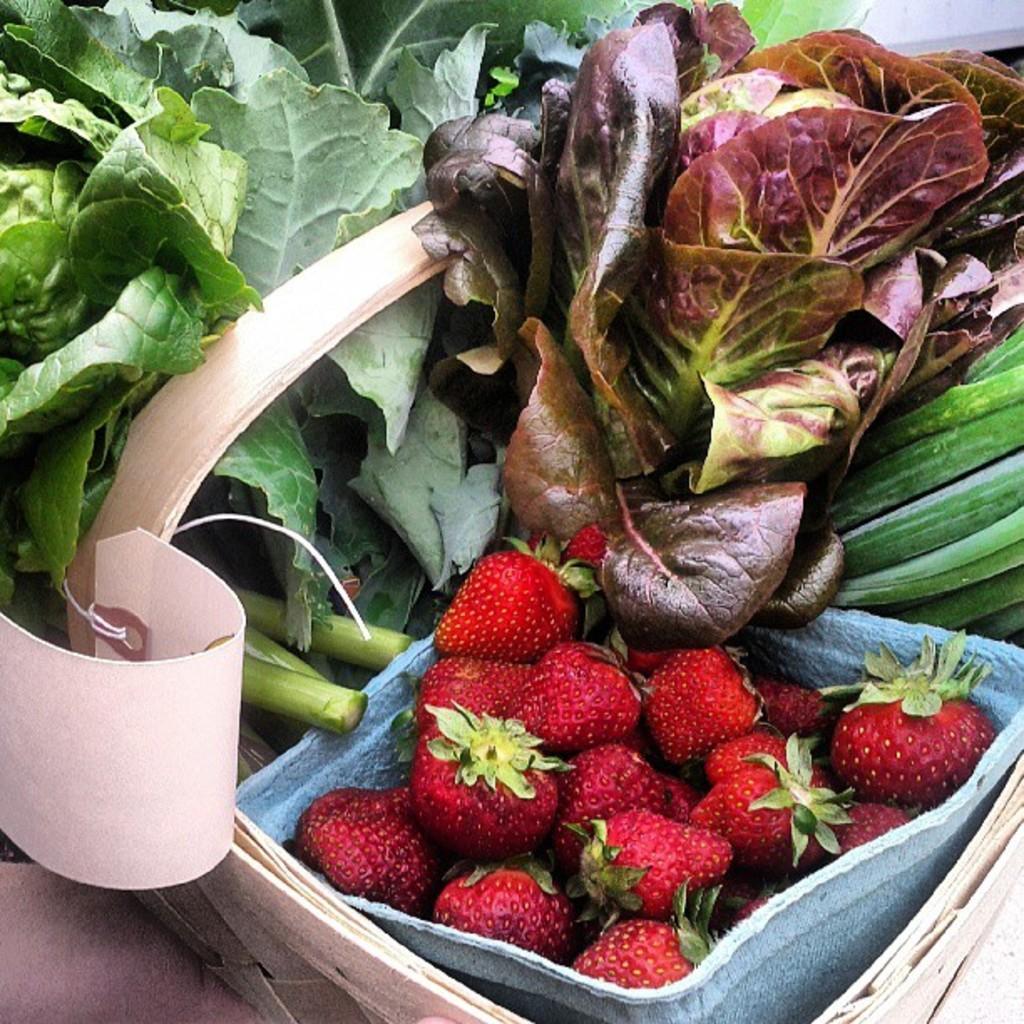Can you describe this image briefly? In this image we can see some strawberries in a bowl, there are some leaves, and cards. 